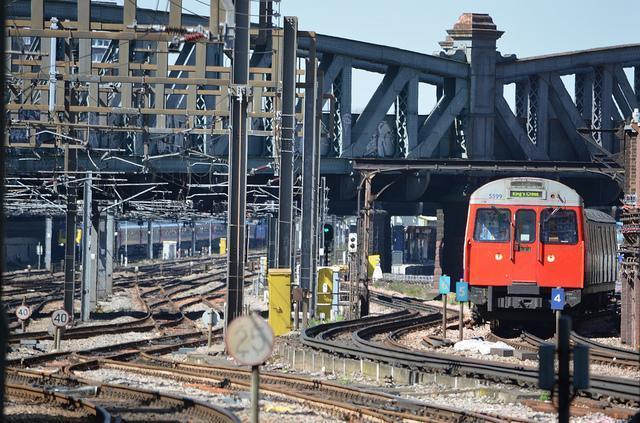How many trains can be seen?
Give a very brief answer. 2. 